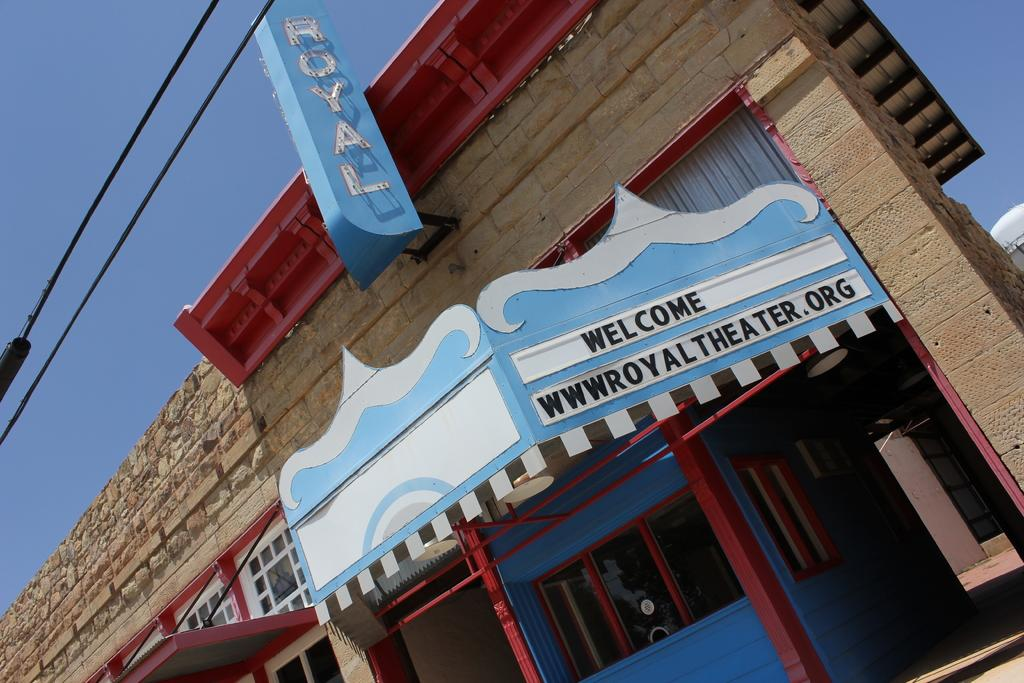<image>
Create a compact narrative representing the image presented. royal theater building which looks closed it has a bug signboard 